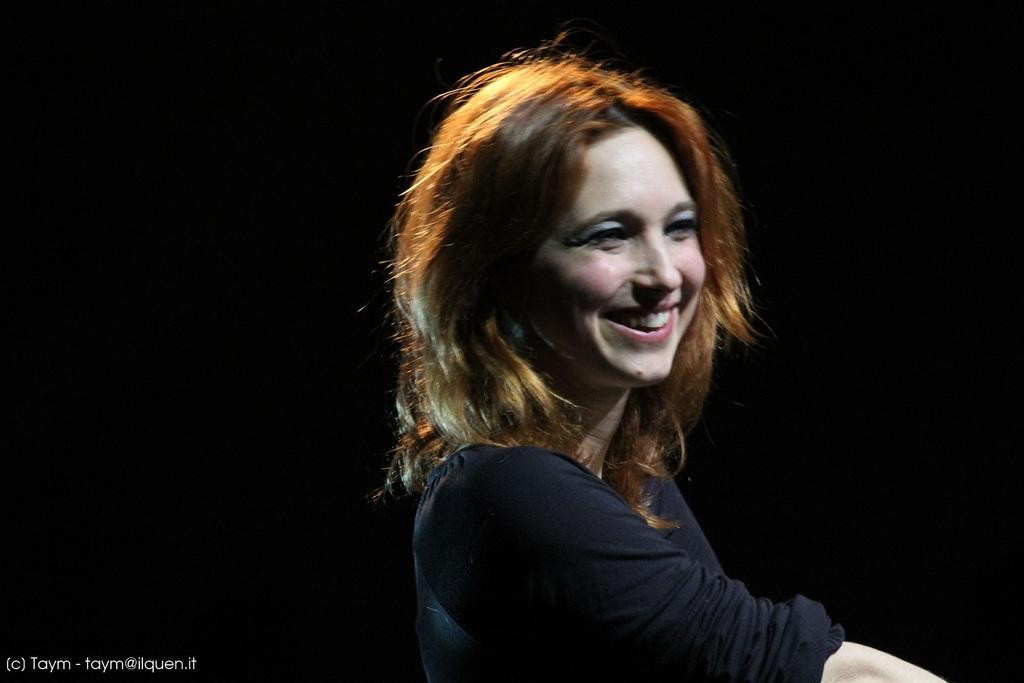Who is present in the image? There is a woman in the image. What is the woman wearing? The woman is wearing a black dress. What expression does the woman have? The woman is smiling. What color is the background of the image? The background of the image is black. Can you see any stars in the image? There are no stars visible in the image; the background is black, but it does not depict any celestial objects. 